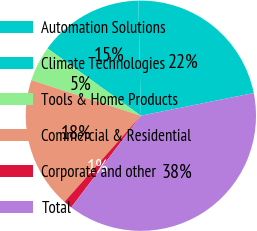<chart> <loc_0><loc_0><loc_500><loc_500><pie_chart><fcel>Automation Solutions<fcel>Climate Technologies<fcel>Tools & Home Products<fcel>Commercial & Residential<fcel>Corporate and other<fcel>Total<nl><fcel>22.18%<fcel>14.72%<fcel>4.94%<fcel>18.45%<fcel>1.21%<fcel>38.5%<nl></chart> 